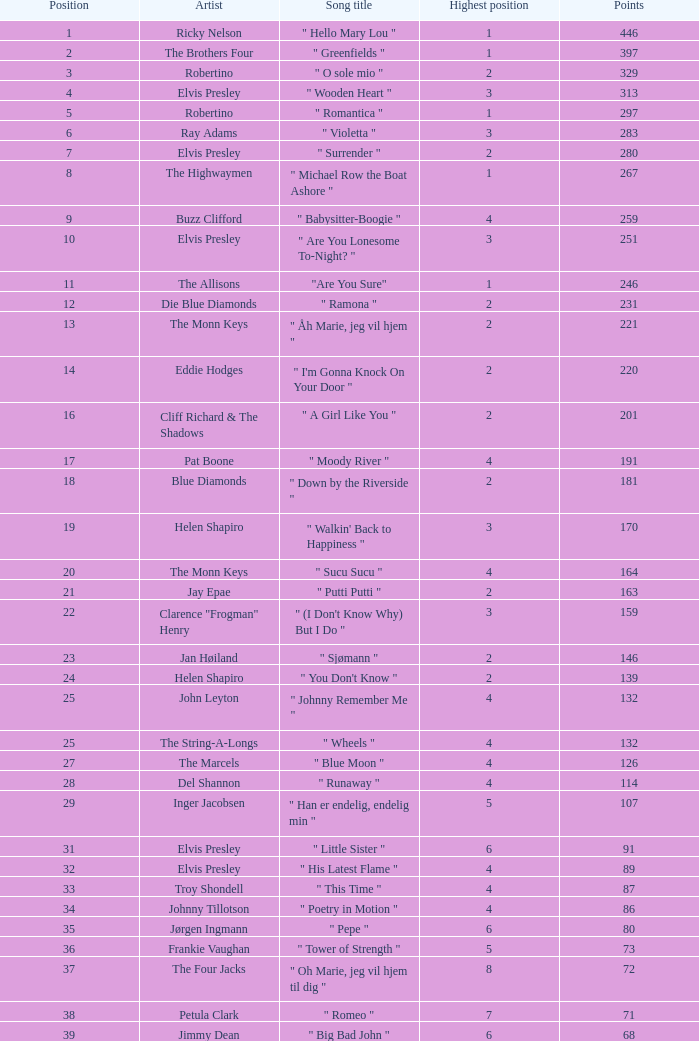What is the title of the song that received 259 points? " Babysitter-Boogie ". 